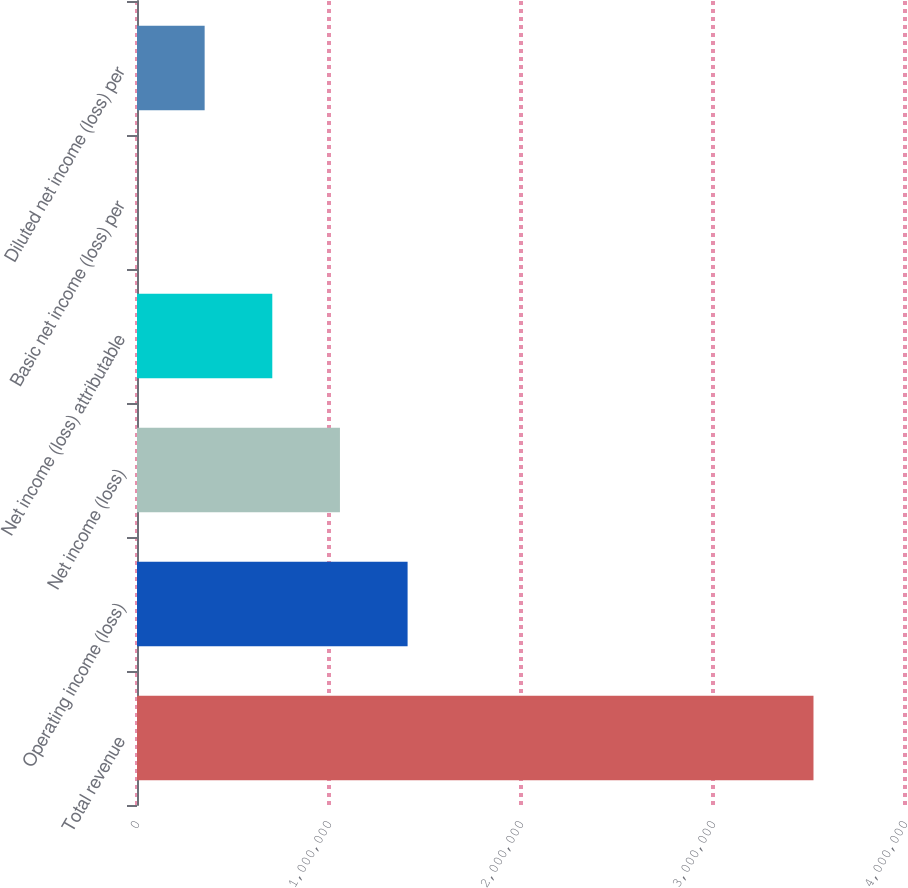Convert chart to OTSL. <chart><loc_0><loc_0><loc_500><loc_500><bar_chart><fcel>Total revenue<fcel>Operating income (loss)<fcel>Net income (loss)<fcel>Net income (loss) attributable<fcel>Basic net income (loss) per<fcel>Diluted net income (loss) per<nl><fcel>3.52335e+06<fcel>1.40934e+06<fcel>1.057e+06<fcel>704670<fcel>0.35<fcel>352335<nl></chart> 